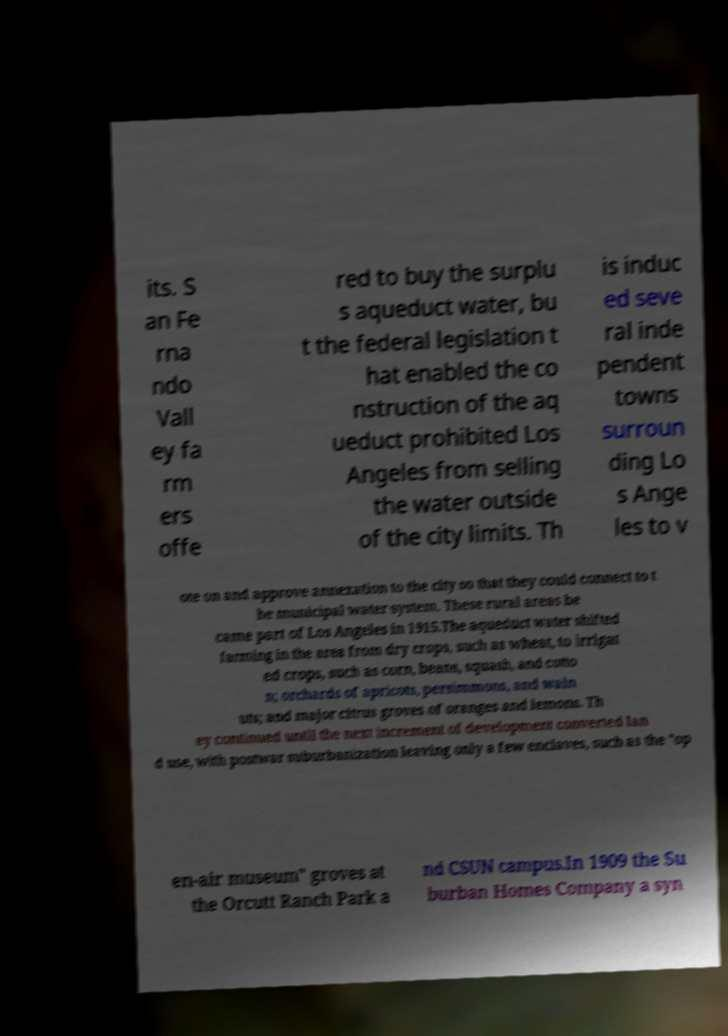Please identify and transcribe the text found in this image. its. S an Fe rna ndo Vall ey fa rm ers offe red to buy the surplu s aqueduct water, bu t the federal legislation t hat enabled the co nstruction of the aq ueduct prohibited Los Angeles from selling the water outside of the city limits. Th is induc ed seve ral inde pendent towns surroun ding Lo s Ange les to v ote on and approve annexation to the city so that they could connect to t he municipal water system. These rural areas be came part of Los Angeles in 1915.The aqueduct water shifted farming in the area from dry crops, such as wheat, to irrigat ed crops, such as corn, beans, squash, and cotto n; orchards of apricots, persimmons, and waln uts; and major citrus groves of oranges and lemons. Th ey continued until the next increment of development converted lan d use, with postwar suburbanization leaving only a few enclaves, such as the "op en-air museum" groves at the Orcutt Ranch Park a nd CSUN campus.In 1909 the Su burban Homes Company a syn 